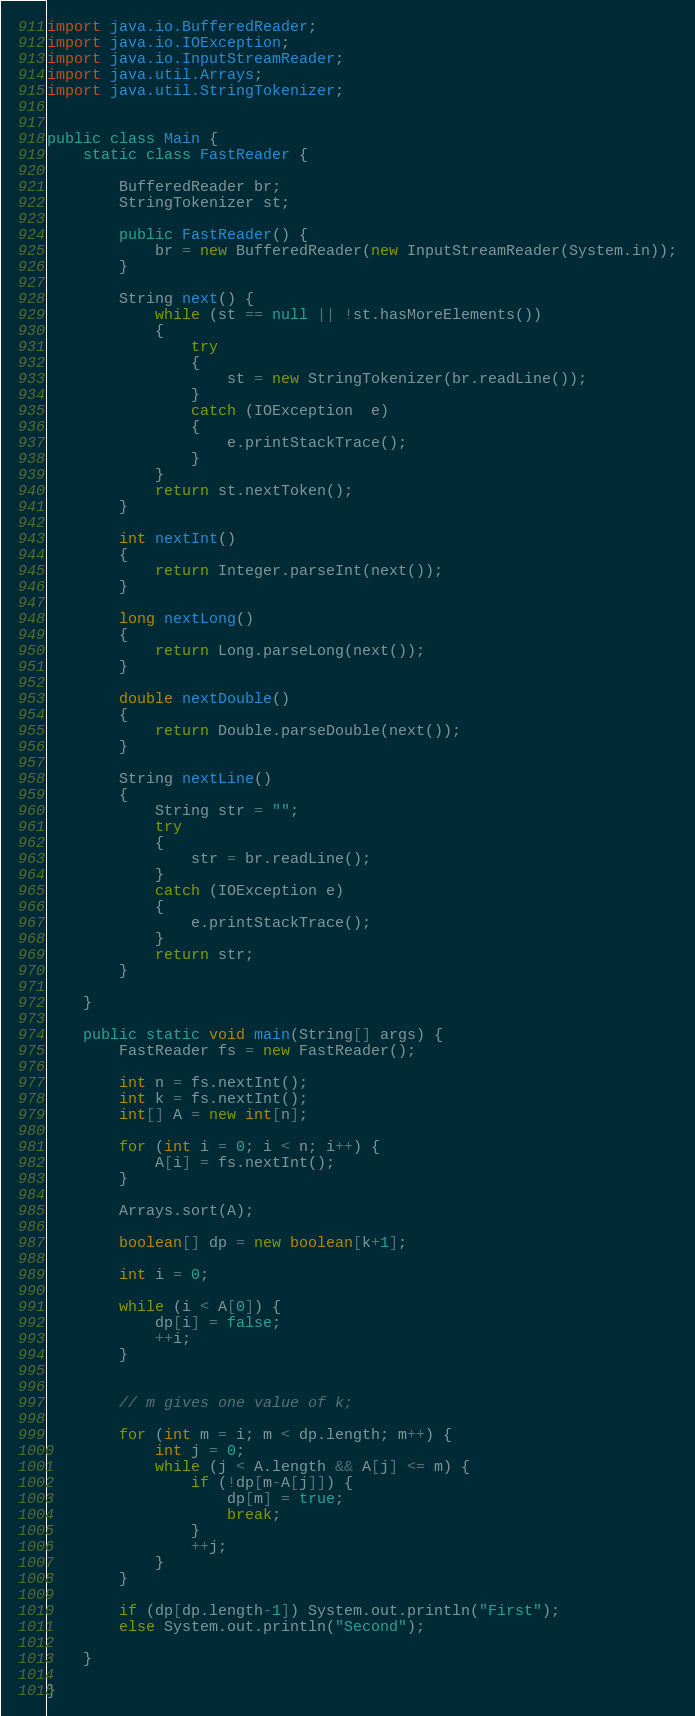Convert code to text. <code><loc_0><loc_0><loc_500><loc_500><_Java_>

import java.io.BufferedReader;
import java.io.IOException;
import java.io.InputStreamReader;
import java.util.Arrays;
import java.util.StringTokenizer;


public class Main {
    static class FastReader {

        BufferedReader br;
        StringTokenizer st;

        public FastReader() {
            br = new BufferedReader(new InputStreamReader(System.in));
        }

        String next() {
            while (st == null || !st.hasMoreElements()) 
            { 
                try
                { 
                    st = new StringTokenizer(br.readLine()); 
                } 
                catch (IOException  e) 
                { 
                    e.printStackTrace(); 
                } 
            } 
            return st.nextToken(); 
        }

        int nextInt() 
        { 
            return Integer.parseInt(next()); 
        } 
  
        long nextLong() 
        { 
            return Long.parseLong(next()); 
        } 
  
        double nextDouble() 
        { 
            return Double.parseDouble(next()); 
        }

        String nextLine() 
        { 
            String str = ""; 
            try
            { 
                str = br.readLine(); 
            } 
            catch (IOException e) 
            { 
                e.printStackTrace(); 
            } 
            return str; 
        } 

    }

    public static void main(String[] args) {
        FastReader fs = new FastReader();
        
        int n = fs.nextInt();
        int k = fs.nextInt();
        int[] A = new int[n];
        
        for (int i = 0; i < n; i++) {
            A[i] = fs.nextInt();
        }
        
        Arrays.sort(A);

        boolean[] dp = new boolean[k+1];

        int i = 0;

        while (i < A[0]) {
            dp[i] = false;
            ++i;
        }


        // m gives one value of k;

        for (int m = i; m < dp.length; m++) {
            int j = 0;
            while (j < A.length && A[j] <= m) {
                if (!dp[m-A[j]]) {
                    dp[m] = true;
                    break;
                }
                ++j;
            }
        }

        if (dp[dp.length-1]) System.out.println("First");
        else System.out.println("Second");

    }

}</code> 